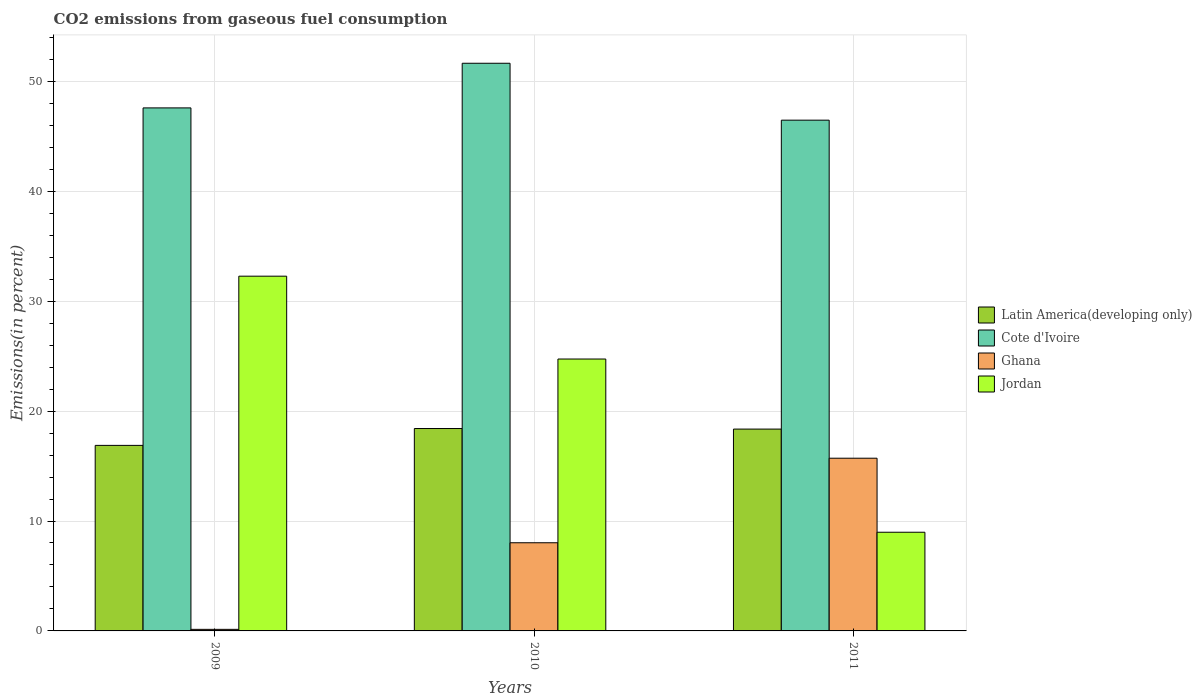How many different coloured bars are there?
Provide a short and direct response. 4. How many groups of bars are there?
Make the answer very short. 3. Are the number of bars per tick equal to the number of legend labels?
Your response must be concise. Yes. How many bars are there on the 2nd tick from the left?
Your answer should be very brief. 4. What is the label of the 1st group of bars from the left?
Provide a short and direct response. 2009. In how many cases, is the number of bars for a given year not equal to the number of legend labels?
Your answer should be very brief. 0. What is the total CO2 emitted in Cote d'Ivoire in 2010?
Ensure brevity in your answer.  51.65. Across all years, what is the maximum total CO2 emitted in Jordan?
Give a very brief answer. 32.28. Across all years, what is the minimum total CO2 emitted in Ghana?
Your answer should be compact. 0.14. In which year was the total CO2 emitted in Latin America(developing only) maximum?
Keep it short and to the point. 2010. What is the total total CO2 emitted in Latin America(developing only) in the graph?
Your answer should be very brief. 53.66. What is the difference between the total CO2 emitted in Ghana in 2009 and that in 2010?
Provide a short and direct response. -7.88. What is the difference between the total CO2 emitted in Ghana in 2011 and the total CO2 emitted in Cote d'Ivoire in 2009?
Make the answer very short. -31.87. What is the average total CO2 emitted in Jordan per year?
Offer a very short reply. 22. In the year 2009, what is the difference between the total CO2 emitted in Ghana and total CO2 emitted in Cote d'Ivoire?
Offer a terse response. -47.45. What is the ratio of the total CO2 emitted in Latin America(developing only) in 2009 to that in 2011?
Provide a short and direct response. 0.92. What is the difference between the highest and the second highest total CO2 emitted in Jordan?
Your answer should be compact. 7.54. What is the difference between the highest and the lowest total CO2 emitted in Latin America(developing only)?
Keep it short and to the point. 1.53. In how many years, is the total CO2 emitted in Jordan greater than the average total CO2 emitted in Jordan taken over all years?
Your answer should be compact. 2. What does the 4th bar from the left in 2010 represents?
Provide a succinct answer. Jordan. What does the 1st bar from the right in 2010 represents?
Keep it short and to the point. Jordan. Is it the case that in every year, the sum of the total CO2 emitted in Ghana and total CO2 emitted in Latin America(developing only) is greater than the total CO2 emitted in Cote d'Ivoire?
Give a very brief answer. No. How many bars are there?
Keep it short and to the point. 12. Are all the bars in the graph horizontal?
Keep it short and to the point. No. How many years are there in the graph?
Keep it short and to the point. 3. Are the values on the major ticks of Y-axis written in scientific E-notation?
Offer a terse response. No. Where does the legend appear in the graph?
Your answer should be compact. Center right. How are the legend labels stacked?
Offer a very short reply. Vertical. What is the title of the graph?
Provide a succinct answer. CO2 emissions from gaseous fuel consumption. What is the label or title of the Y-axis?
Keep it short and to the point. Emissions(in percent). What is the Emissions(in percent) in Latin America(developing only) in 2009?
Provide a succinct answer. 16.88. What is the Emissions(in percent) of Cote d'Ivoire in 2009?
Make the answer very short. 47.59. What is the Emissions(in percent) of Ghana in 2009?
Your response must be concise. 0.14. What is the Emissions(in percent) in Jordan in 2009?
Keep it short and to the point. 32.28. What is the Emissions(in percent) of Latin America(developing only) in 2010?
Offer a very short reply. 18.42. What is the Emissions(in percent) of Cote d'Ivoire in 2010?
Make the answer very short. 51.65. What is the Emissions(in percent) in Ghana in 2010?
Give a very brief answer. 8.02. What is the Emissions(in percent) of Jordan in 2010?
Offer a terse response. 24.74. What is the Emissions(in percent) of Latin America(developing only) in 2011?
Provide a short and direct response. 18.36. What is the Emissions(in percent) in Cote d'Ivoire in 2011?
Provide a short and direct response. 46.47. What is the Emissions(in percent) of Ghana in 2011?
Give a very brief answer. 15.71. What is the Emissions(in percent) of Jordan in 2011?
Make the answer very short. 8.98. Across all years, what is the maximum Emissions(in percent) of Latin America(developing only)?
Your answer should be compact. 18.42. Across all years, what is the maximum Emissions(in percent) in Cote d'Ivoire?
Make the answer very short. 51.65. Across all years, what is the maximum Emissions(in percent) of Ghana?
Provide a short and direct response. 15.71. Across all years, what is the maximum Emissions(in percent) of Jordan?
Ensure brevity in your answer.  32.28. Across all years, what is the minimum Emissions(in percent) of Latin America(developing only)?
Give a very brief answer. 16.88. Across all years, what is the minimum Emissions(in percent) in Cote d'Ivoire?
Offer a terse response. 46.47. Across all years, what is the minimum Emissions(in percent) of Ghana?
Ensure brevity in your answer.  0.14. Across all years, what is the minimum Emissions(in percent) in Jordan?
Ensure brevity in your answer.  8.98. What is the total Emissions(in percent) of Latin America(developing only) in the graph?
Your answer should be very brief. 53.66. What is the total Emissions(in percent) of Cote d'Ivoire in the graph?
Provide a succinct answer. 145.71. What is the total Emissions(in percent) of Ghana in the graph?
Provide a succinct answer. 23.88. What is the total Emissions(in percent) in Jordan in the graph?
Give a very brief answer. 66. What is the difference between the Emissions(in percent) in Latin America(developing only) in 2009 and that in 2010?
Offer a terse response. -1.53. What is the difference between the Emissions(in percent) of Cote d'Ivoire in 2009 and that in 2010?
Your answer should be compact. -4.06. What is the difference between the Emissions(in percent) of Ghana in 2009 and that in 2010?
Ensure brevity in your answer.  -7.88. What is the difference between the Emissions(in percent) of Jordan in 2009 and that in 2010?
Offer a terse response. 7.54. What is the difference between the Emissions(in percent) in Latin America(developing only) in 2009 and that in 2011?
Offer a very short reply. -1.48. What is the difference between the Emissions(in percent) in Cote d'Ivoire in 2009 and that in 2011?
Offer a very short reply. 1.12. What is the difference between the Emissions(in percent) of Ghana in 2009 and that in 2011?
Your answer should be very brief. -15.57. What is the difference between the Emissions(in percent) in Jordan in 2009 and that in 2011?
Your response must be concise. 23.3. What is the difference between the Emissions(in percent) in Latin America(developing only) in 2010 and that in 2011?
Your response must be concise. 0.05. What is the difference between the Emissions(in percent) in Cote d'Ivoire in 2010 and that in 2011?
Ensure brevity in your answer.  5.18. What is the difference between the Emissions(in percent) in Ghana in 2010 and that in 2011?
Keep it short and to the point. -7.69. What is the difference between the Emissions(in percent) of Jordan in 2010 and that in 2011?
Ensure brevity in your answer.  15.76. What is the difference between the Emissions(in percent) in Latin America(developing only) in 2009 and the Emissions(in percent) in Cote d'Ivoire in 2010?
Keep it short and to the point. -34.77. What is the difference between the Emissions(in percent) in Latin America(developing only) in 2009 and the Emissions(in percent) in Ghana in 2010?
Keep it short and to the point. 8.86. What is the difference between the Emissions(in percent) of Latin America(developing only) in 2009 and the Emissions(in percent) of Jordan in 2010?
Your response must be concise. -7.86. What is the difference between the Emissions(in percent) of Cote d'Ivoire in 2009 and the Emissions(in percent) of Ghana in 2010?
Your response must be concise. 39.57. What is the difference between the Emissions(in percent) of Cote d'Ivoire in 2009 and the Emissions(in percent) of Jordan in 2010?
Provide a succinct answer. 22.85. What is the difference between the Emissions(in percent) of Ghana in 2009 and the Emissions(in percent) of Jordan in 2010?
Offer a terse response. -24.6. What is the difference between the Emissions(in percent) of Latin America(developing only) in 2009 and the Emissions(in percent) of Cote d'Ivoire in 2011?
Ensure brevity in your answer.  -29.59. What is the difference between the Emissions(in percent) of Latin America(developing only) in 2009 and the Emissions(in percent) of Ghana in 2011?
Keep it short and to the point. 1.17. What is the difference between the Emissions(in percent) in Latin America(developing only) in 2009 and the Emissions(in percent) in Jordan in 2011?
Provide a succinct answer. 7.9. What is the difference between the Emissions(in percent) in Cote d'Ivoire in 2009 and the Emissions(in percent) in Ghana in 2011?
Your answer should be compact. 31.87. What is the difference between the Emissions(in percent) in Cote d'Ivoire in 2009 and the Emissions(in percent) in Jordan in 2011?
Your answer should be very brief. 38.61. What is the difference between the Emissions(in percent) in Ghana in 2009 and the Emissions(in percent) in Jordan in 2011?
Your answer should be compact. -8.84. What is the difference between the Emissions(in percent) of Latin America(developing only) in 2010 and the Emissions(in percent) of Cote d'Ivoire in 2011?
Ensure brevity in your answer.  -28.06. What is the difference between the Emissions(in percent) of Latin America(developing only) in 2010 and the Emissions(in percent) of Ghana in 2011?
Provide a short and direct response. 2.7. What is the difference between the Emissions(in percent) of Latin America(developing only) in 2010 and the Emissions(in percent) of Jordan in 2011?
Provide a succinct answer. 9.44. What is the difference between the Emissions(in percent) in Cote d'Ivoire in 2010 and the Emissions(in percent) in Ghana in 2011?
Keep it short and to the point. 35.94. What is the difference between the Emissions(in percent) in Cote d'Ivoire in 2010 and the Emissions(in percent) in Jordan in 2011?
Your answer should be very brief. 42.67. What is the difference between the Emissions(in percent) in Ghana in 2010 and the Emissions(in percent) in Jordan in 2011?
Offer a very short reply. -0.96. What is the average Emissions(in percent) in Latin America(developing only) per year?
Provide a succinct answer. 17.89. What is the average Emissions(in percent) of Cote d'Ivoire per year?
Your response must be concise. 48.57. What is the average Emissions(in percent) of Ghana per year?
Your answer should be very brief. 7.96. What is the average Emissions(in percent) of Jordan per year?
Give a very brief answer. 22. In the year 2009, what is the difference between the Emissions(in percent) of Latin America(developing only) and Emissions(in percent) of Cote d'Ivoire?
Your response must be concise. -30.71. In the year 2009, what is the difference between the Emissions(in percent) of Latin America(developing only) and Emissions(in percent) of Ghana?
Keep it short and to the point. 16.74. In the year 2009, what is the difference between the Emissions(in percent) in Latin America(developing only) and Emissions(in percent) in Jordan?
Offer a very short reply. -15.4. In the year 2009, what is the difference between the Emissions(in percent) in Cote d'Ivoire and Emissions(in percent) in Ghana?
Offer a very short reply. 47.45. In the year 2009, what is the difference between the Emissions(in percent) in Cote d'Ivoire and Emissions(in percent) in Jordan?
Keep it short and to the point. 15.31. In the year 2009, what is the difference between the Emissions(in percent) in Ghana and Emissions(in percent) in Jordan?
Offer a terse response. -32.14. In the year 2010, what is the difference between the Emissions(in percent) in Latin America(developing only) and Emissions(in percent) in Cote d'Ivoire?
Your answer should be compact. -33.24. In the year 2010, what is the difference between the Emissions(in percent) in Latin America(developing only) and Emissions(in percent) in Ghana?
Offer a terse response. 10.39. In the year 2010, what is the difference between the Emissions(in percent) of Latin America(developing only) and Emissions(in percent) of Jordan?
Keep it short and to the point. -6.32. In the year 2010, what is the difference between the Emissions(in percent) in Cote d'Ivoire and Emissions(in percent) in Ghana?
Offer a very short reply. 43.63. In the year 2010, what is the difference between the Emissions(in percent) of Cote d'Ivoire and Emissions(in percent) of Jordan?
Provide a short and direct response. 26.91. In the year 2010, what is the difference between the Emissions(in percent) of Ghana and Emissions(in percent) of Jordan?
Ensure brevity in your answer.  -16.72. In the year 2011, what is the difference between the Emissions(in percent) of Latin America(developing only) and Emissions(in percent) of Cote d'Ivoire?
Make the answer very short. -28.11. In the year 2011, what is the difference between the Emissions(in percent) of Latin America(developing only) and Emissions(in percent) of Ghana?
Provide a short and direct response. 2.65. In the year 2011, what is the difference between the Emissions(in percent) in Latin America(developing only) and Emissions(in percent) in Jordan?
Your answer should be compact. 9.39. In the year 2011, what is the difference between the Emissions(in percent) of Cote d'Ivoire and Emissions(in percent) of Ghana?
Provide a short and direct response. 30.76. In the year 2011, what is the difference between the Emissions(in percent) of Cote d'Ivoire and Emissions(in percent) of Jordan?
Offer a terse response. 37.49. In the year 2011, what is the difference between the Emissions(in percent) of Ghana and Emissions(in percent) of Jordan?
Keep it short and to the point. 6.74. What is the ratio of the Emissions(in percent) of Cote d'Ivoire in 2009 to that in 2010?
Offer a terse response. 0.92. What is the ratio of the Emissions(in percent) in Ghana in 2009 to that in 2010?
Your answer should be compact. 0.02. What is the ratio of the Emissions(in percent) in Jordan in 2009 to that in 2010?
Your answer should be compact. 1.3. What is the ratio of the Emissions(in percent) in Latin America(developing only) in 2009 to that in 2011?
Give a very brief answer. 0.92. What is the ratio of the Emissions(in percent) in Ghana in 2009 to that in 2011?
Offer a very short reply. 0.01. What is the ratio of the Emissions(in percent) in Jordan in 2009 to that in 2011?
Provide a succinct answer. 3.6. What is the ratio of the Emissions(in percent) in Latin America(developing only) in 2010 to that in 2011?
Your response must be concise. 1. What is the ratio of the Emissions(in percent) in Cote d'Ivoire in 2010 to that in 2011?
Your response must be concise. 1.11. What is the ratio of the Emissions(in percent) of Ghana in 2010 to that in 2011?
Your answer should be compact. 0.51. What is the ratio of the Emissions(in percent) of Jordan in 2010 to that in 2011?
Keep it short and to the point. 2.76. What is the difference between the highest and the second highest Emissions(in percent) of Latin America(developing only)?
Provide a short and direct response. 0.05. What is the difference between the highest and the second highest Emissions(in percent) in Cote d'Ivoire?
Your answer should be compact. 4.06. What is the difference between the highest and the second highest Emissions(in percent) in Ghana?
Your response must be concise. 7.69. What is the difference between the highest and the second highest Emissions(in percent) in Jordan?
Make the answer very short. 7.54. What is the difference between the highest and the lowest Emissions(in percent) of Latin America(developing only)?
Provide a succinct answer. 1.53. What is the difference between the highest and the lowest Emissions(in percent) in Cote d'Ivoire?
Offer a terse response. 5.18. What is the difference between the highest and the lowest Emissions(in percent) of Ghana?
Ensure brevity in your answer.  15.57. What is the difference between the highest and the lowest Emissions(in percent) of Jordan?
Your response must be concise. 23.3. 